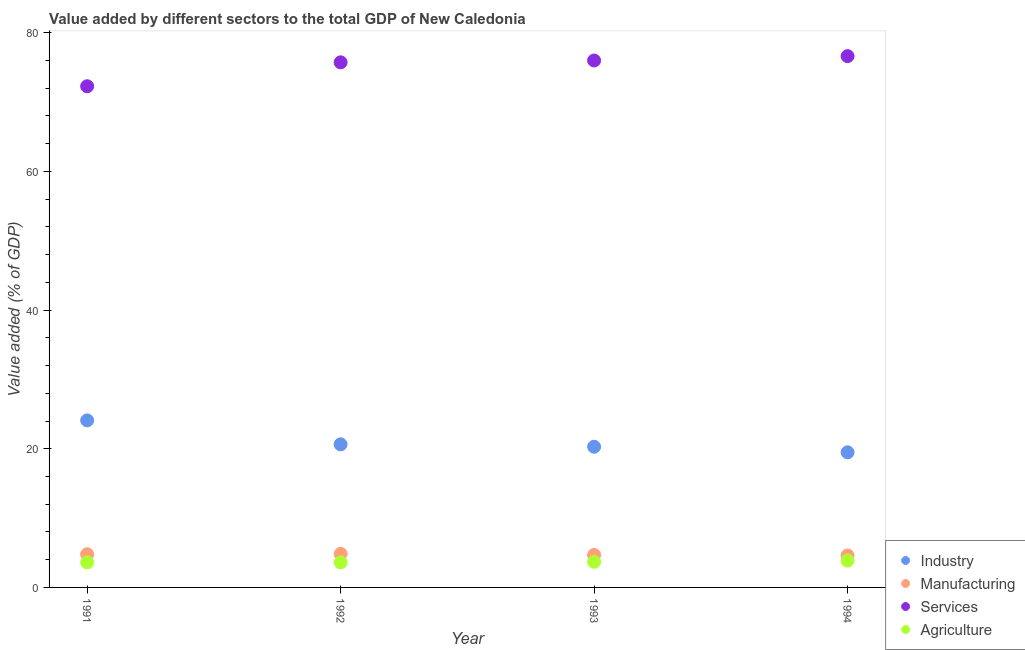What is the value added by services sector in 1993?
Provide a short and direct response. 76. Across all years, what is the maximum value added by agricultural sector?
Your answer should be compact. 3.88. Across all years, what is the minimum value added by industrial sector?
Offer a terse response. 19.49. In which year was the value added by agricultural sector minimum?
Keep it short and to the point. 1991. What is the total value added by agricultural sector in the graph?
Make the answer very short. 14.82. What is the difference between the value added by manufacturing sector in 1993 and that in 1994?
Make the answer very short. 0.08. What is the difference between the value added by industrial sector in 1993 and the value added by agricultural sector in 1992?
Offer a very short reply. 16.67. What is the average value added by industrial sector per year?
Offer a terse response. 21.13. In the year 1991, what is the difference between the value added by manufacturing sector and value added by agricultural sector?
Offer a terse response. 1.17. What is the ratio of the value added by services sector in 1992 to that in 1993?
Keep it short and to the point. 1. Is the value added by services sector in 1991 less than that in 1994?
Provide a short and direct response. Yes. Is the difference between the value added by industrial sector in 1992 and 1994 greater than the difference between the value added by services sector in 1992 and 1994?
Provide a succinct answer. Yes. What is the difference between the highest and the second highest value added by manufacturing sector?
Provide a short and direct response. 0.05. What is the difference between the highest and the lowest value added by services sector?
Make the answer very short. 4.35. In how many years, is the value added by manufacturing sector greater than the average value added by manufacturing sector taken over all years?
Your answer should be very brief. 2. Is it the case that in every year, the sum of the value added by agricultural sector and value added by services sector is greater than the sum of value added by manufacturing sector and value added by industrial sector?
Your answer should be very brief. No. Is it the case that in every year, the sum of the value added by industrial sector and value added by manufacturing sector is greater than the value added by services sector?
Offer a very short reply. No. Is the value added by industrial sector strictly greater than the value added by manufacturing sector over the years?
Your answer should be compact. Yes. Are the values on the major ticks of Y-axis written in scientific E-notation?
Offer a terse response. No. How many legend labels are there?
Provide a short and direct response. 4. How are the legend labels stacked?
Provide a short and direct response. Vertical. What is the title of the graph?
Provide a short and direct response. Value added by different sectors to the total GDP of New Caledonia. What is the label or title of the X-axis?
Provide a succinct answer. Year. What is the label or title of the Y-axis?
Ensure brevity in your answer.  Value added (% of GDP). What is the Value added (% of GDP) in Industry in 1991?
Your answer should be very brief. 24.09. What is the Value added (% of GDP) of Manufacturing in 1991?
Your answer should be very brief. 4.79. What is the Value added (% of GDP) of Services in 1991?
Give a very brief answer. 72.29. What is the Value added (% of GDP) of Agriculture in 1991?
Your answer should be compact. 3.62. What is the Value added (% of GDP) of Industry in 1992?
Provide a succinct answer. 20.64. What is the Value added (% of GDP) of Manufacturing in 1992?
Provide a succinct answer. 4.84. What is the Value added (% of GDP) of Services in 1992?
Your answer should be very brief. 75.74. What is the Value added (% of GDP) of Agriculture in 1992?
Make the answer very short. 3.62. What is the Value added (% of GDP) in Industry in 1993?
Offer a very short reply. 20.29. What is the Value added (% of GDP) in Manufacturing in 1993?
Offer a terse response. 4.69. What is the Value added (% of GDP) in Services in 1993?
Ensure brevity in your answer.  76. What is the Value added (% of GDP) of Agriculture in 1993?
Give a very brief answer. 3.7. What is the Value added (% of GDP) in Industry in 1994?
Offer a very short reply. 19.49. What is the Value added (% of GDP) of Manufacturing in 1994?
Your response must be concise. 4.61. What is the Value added (% of GDP) of Services in 1994?
Offer a very short reply. 76.63. What is the Value added (% of GDP) of Agriculture in 1994?
Give a very brief answer. 3.88. Across all years, what is the maximum Value added (% of GDP) of Industry?
Offer a terse response. 24.09. Across all years, what is the maximum Value added (% of GDP) in Manufacturing?
Offer a terse response. 4.84. Across all years, what is the maximum Value added (% of GDP) of Services?
Your answer should be compact. 76.63. Across all years, what is the maximum Value added (% of GDP) in Agriculture?
Provide a short and direct response. 3.88. Across all years, what is the minimum Value added (% of GDP) of Industry?
Give a very brief answer. 19.49. Across all years, what is the minimum Value added (% of GDP) of Manufacturing?
Your response must be concise. 4.61. Across all years, what is the minimum Value added (% of GDP) of Services?
Your answer should be very brief. 72.29. Across all years, what is the minimum Value added (% of GDP) in Agriculture?
Offer a very short reply. 3.62. What is the total Value added (% of GDP) in Industry in the graph?
Your answer should be very brief. 84.52. What is the total Value added (% of GDP) of Manufacturing in the graph?
Provide a short and direct response. 18.93. What is the total Value added (% of GDP) of Services in the graph?
Your answer should be compact. 300.67. What is the total Value added (% of GDP) of Agriculture in the graph?
Make the answer very short. 14.82. What is the difference between the Value added (% of GDP) of Industry in 1991 and that in 1992?
Keep it short and to the point. 3.45. What is the difference between the Value added (% of GDP) in Manufacturing in 1991 and that in 1992?
Ensure brevity in your answer.  -0.05. What is the difference between the Value added (% of GDP) in Services in 1991 and that in 1992?
Offer a terse response. -3.45. What is the difference between the Value added (% of GDP) in Agriculture in 1991 and that in 1992?
Provide a short and direct response. -0. What is the difference between the Value added (% of GDP) of Industry in 1991 and that in 1993?
Ensure brevity in your answer.  3.8. What is the difference between the Value added (% of GDP) in Manufacturing in 1991 and that in 1993?
Your answer should be very brief. 0.1. What is the difference between the Value added (% of GDP) in Services in 1991 and that in 1993?
Offer a very short reply. -3.72. What is the difference between the Value added (% of GDP) in Agriculture in 1991 and that in 1993?
Your answer should be compact. -0.08. What is the difference between the Value added (% of GDP) in Industry in 1991 and that in 1994?
Offer a terse response. 4.6. What is the difference between the Value added (% of GDP) of Manufacturing in 1991 and that in 1994?
Offer a very short reply. 0.18. What is the difference between the Value added (% of GDP) of Services in 1991 and that in 1994?
Offer a very short reply. -4.35. What is the difference between the Value added (% of GDP) of Agriculture in 1991 and that in 1994?
Your answer should be compact. -0.26. What is the difference between the Value added (% of GDP) of Industry in 1992 and that in 1993?
Make the answer very short. 0.35. What is the difference between the Value added (% of GDP) in Manufacturing in 1992 and that in 1993?
Your response must be concise. 0.15. What is the difference between the Value added (% of GDP) in Services in 1992 and that in 1993?
Ensure brevity in your answer.  -0.26. What is the difference between the Value added (% of GDP) in Agriculture in 1992 and that in 1993?
Provide a short and direct response. -0.08. What is the difference between the Value added (% of GDP) of Industry in 1992 and that in 1994?
Your response must be concise. 1.15. What is the difference between the Value added (% of GDP) in Manufacturing in 1992 and that in 1994?
Provide a succinct answer. 0.23. What is the difference between the Value added (% of GDP) of Services in 1992 and that in 1994?
Ensure brevity in your answer.  -0.89. What is the difference between the Value added (% of GDP) in Agriculture in 1992 and that in 1994?
Your response must be concise. -0.26. What is the difference between the Value added (% of GDP) of Industry in 1993 and that in 1994?
Keep it short and to the point. 0.8. What is the difference between the Value added (% of GDP) of Manufacturing in 1993 and that in 1994?
Provide a succinct answer. 0.08. What is the difference between the Value added (% of GDP) in Services in 1993 and that in 1994?
Your answer should be compact. -0.63. What is the difference between the Value added (% of GDP) in Agriculture in 1993 and that in 1994?
Your response must be concise. -0.17. What is the difference between the Value added (% of GDP) in Industry in 1991 and the Value added (% of GDP) in Manufacturing in 1992?
Your answer should be compact. 19.25. What is the difference between the Value added (% of GDP) in Industry in 1991 and the Value added (% of GDP) in Services in 1992?
Your answer should be compact. -51.65. What is the difference between the Value added (% of GDP) of Industry in 1991 and the Value added (% of GDP) of Agriculture in 1992?
Offer a very short reply. 20.47. What is the difference between the Value added (% of GDP) in Manufacturing in 1991 and the Value added (% of GDP) in Services in 1992?
Offer a very short reply. -70.95. What is the difference between the Value added (% of GDP) in Manufacturing in 1991 and the Value added (% of GDP) in Agriculture in 1992?
Offer a very short reply. 1.17. What is the difference between the Value added (% of GDP) of Services in 1991 and the Value added (% of GDP) of Agriculture in 1992?
Keep it short and to the point. 68.67. What is the difference between the Value added (% of GDP) of Industry in 1991 and the Value added (% of GDP) of Manufacturing in 1993?
Keep it short and to the point. 19.4. What is the difference between the Value added (% of GDP) in Industry in 1991 and the Value added (% of GDP) in Services in 1993?
Your answer should be very brief. -51.91. What is the difference between the Value added (% of GDP) in Industry in 1991 and the Value added (% of GDP) in Agriculture in 1993?
Ensure brevity in your answer.  20.39. What is the difference between the Value added (% of GDP) in Manufacturing in 1991 and the Value added (% of GDP) in Services in 1993?
Give a very brief answer. -71.22. What is the difference between the Value added (% of GDP) in Manufacturing in 1991 and the Value added (% of GDP) in Agriculture in 1993?
Ensure brevity in your answer.  1.08. What is the difference between the Value added (% of GDP) of Services in 1991 and the Value added (% of GDP) of Agriculture in 1993?
Make the answer very short. 68.59. What is the difference between the Value added (% of GDP) in Industry in 1991 and the Value added (% of GDP) in Manufacturing in 1994?
Your answer should be compact. 19.48. What is the difference between the Value added (% of GDP) in Industry in 1991 and the Value added (% of GDP) in Services in 1994?
Make the answer very short. -52.54. What is the difference between the Value added (% of GDP) in Industry in 1991 and the Value added (% of GDP) in Agriculture in 1994?
Offer a terse response. 20.22. What is the difference between the Value added (% of GDP) of Manufacturing in 1991 and the Value added (% of GDP) of Services in 1994?
Your answer should be very brief. -71.85. What is the difference between the Value added (% of GDP) of Manufacturing in 1991 and the Value added (% of GDP) of Agriculture in 1994?
Give a very brief answer. 0.91. What is the difference between the Value added (% of GDP) of Services in 1991 and the Value added (% of GDP) of Agriculture in 1994?
Your response must be concise. 68.41. What is the difference between the Value added (% of GDP) in Industry in 1992 and the Value added (% of GDP) in Manufacturing in 1993?
Give a very brief answer. 15.95. What is the difference between the Value added (% of GDP) in Industry in 1992 and the Value added (% of GDP) in Services in 1993?
Make the answer very short. -55.36. What is the difference between the Value added (% of GDP) of Industry in 1992 and the Value added (% of GDP) of Agriculture in 1993?
Provide a short and direct response. 16.94. What is the difference between the Value added (% of GDP) in Manufacturing in 1992 and the Value added (% of GDP) in Services in 1993?
Provide a succinct answer. -71.16. What is the difference between the Value added (% of GDP) of Manufacturing in 1992 and the Value added (% of GDP) of Agriculture in 1993?
Keep it short and to the point. 1.14. What is the difference between the Value added (% of GDP) of Services in 1992 and the Value added (% of GDP) of Agriculture in 1993?
Offer a very short reply. 72.04. What is the difference between the Value added (% of GDP) in Industry in 1992 and the Value added (% of GDP) in Manufacturing in 1994?
Your response must be concise. 16.03. What is the difference between the Value added (% of GDP) in Industry in 1992 and the Value added (% of GDP) in Services in 1994?
Make the answer very short. -55.99. What is the difference between the Value added (% of GDP) in Industry in 1992 and the Value added (% of GDP) in Agriculture in 1994?
Provide a succinct answer. 16.76. What is the difference between the Value added (% of GDP) in Manufacturing in 1992 and the Value added (% of GDP) in Services in 1994?
Keep it short and to the point. -71.79. What is the difference between the Value added (% of GDP) in Manufacturing in 1992 and the Value added (% of GDP) in Agriculture in 1994?
Make the answer very short. 0.96. What is the difference between the Value added (% of GDP) in Services in 1992 and the Value added (% of GDP) in Agriculture in 1994?
Provide a short and direct response. 71.86. What is the difference between the Value added (% of GDP) in Industry in 1993 and the Value added (% of GDP) in Manufacturing in 1994?
Make the answer very short. 15.68. What is the difference between the Value added (% of GDP) of Industry in 1993 and the Value added (% of GDP) of Services in 1994?
Keep it short and to the point. -56.34. What is the difference between the Value added (% of GDP) of Industry in 1993 and the Value added (% of GDP) of Agriculture in 1994?
Make the answer very short. 16.42. What is the difference between the Value added (% of GDP) in Manufacturing in 1993 and the Value added (% of GDP) in Services in 1994?
Make the answer very short. -71.95. What is the difference between the Value added (% of GDP) in Manufacturing in 1993 and the Value added (% of GDP) in Agriculture in 1994?
Ensure brevity in your answer.  0.81. What is the difference between the Value added (% of GDP) of Services in 1993 and the Value added (% of GDP) of Agriculture in 1994?
Make the answer very short. 72.13. What is the average Value added (% of GDP) of Industry per year?
Provide a succinct answer. 21.13. What is the average Value added (% of GDP) in Manufacturing per year?
Keep it short and to the point. 4.73. What is the average Value added (% of GDP) in Services per year?
Provide a short and direct response. 75.17. What is the average Value added (% of GDP) in Agriculture per year?
Make the answer very short. 3.7. In the year 1991, what is the difference between the Value added (% of GDP) of Industry and Value added (% of GDP) of Manufacturing?
Ensure brevity in your answer.  19.31. In the year 1991, what is the difference between the Value added (% of GDP) of Industry and Value added (% of GDP) of Services?
Provide a short and direct response. -48.19. In the year 1991, what is the difference between the Value added (% of GDP) of Industry and Value added (% of GDP) of Agriculture?
Make the answer very short. 20.47. In the year 1991, what is the difference between the Value added (% of GDP) in Manufacturing and Value added (% of GDP) in Services?
Make the answer very short. -67.5. In the year 1991, what is the difference between the Value added (% of GDP) in Manufacturing and Value added (% of GDP) in Agriculture?
Offer a very short reply. 1.17. In the year 1991, what is the difference between the Value added (% of GDP) of Services and Value added (% of GDP) of Agriculture?
Your response must be concise. 68.67. In the year 1992, what is the difference between the Value added (% of GDP) in Industry and Value added (% of GDP) in Manufacturing?
Provide a short and direct response. 15.8. In the year 1992, what is the difference between the Value added (% of GDP) in Industry and Value added (% of GDP) in Services?
Give a very brief answer. -55.1. In the year 1992, what is the difference between the Value added (% of GDP) in Industry and Value added (% of GDP) in Agriculture?
Make the answer very short. 17.02. In the year 1992, what is the difference between the Value added (% of GDP) in Manufacturing and Value added (% of GDP) in Services?
Your answer should be compact. -70.9. In the year 1992, what is the difference between the Value added (% of GDP) of Manufacturing and Value added (% of GDP) of Agriculture?
Your answer should be compact. 1.22. In the year 1992, what is the difference between the Value added (% of GDP) of Services and Value added (% of GDP) of Agriculture?
Ensure brevity in your answer.  72.12. In the year 1993, what is the difference between the Value added (% of GDP) in Industry and Value added (% of GDP) in Manufacturing?
Give a very brief answer. 15.6. In the year 1993, what is the difference between the Value added (% of GDP) of Industry and Value added (% of GDP) of Services?
Your answer should be very brief. -55.71. In the year 1993, what is the difference between the Value added (% of GDP) of Industry and Value added (% of GDP) of Agriculture?
Your answer should be compact. 16.59. In the year 1993, what is the difference between the Value added (% of GDP) in Manufacturing and Value added (% of GDP) in Services?
Provide a short and direct response. -71.32. In the year 1993, what is the difference between the Value added (% of GDP) in Manufacturing and Value added (% of GDP) in Agriculture?
Ensure brevity in your answer.  0.99. In the year 1993, what is the difference between the Value added (% of GDP) in Services and Value added (% of GDP) in Agriculture?
Give a very brief answer. 72.3. In the year 1994, what is the difference between the Value added (% of GDP) of Industry and Value added (% of GDP) of Manufacturing?
Offer a very short reply. 14.88. In the year 1994, what is the difference between the Value added (% of GDP) in Industry and Value added (% of GDP) in Services?
Provide a succinct answer. -57.14. In the year 1994, what is the difference between the Value added (% of GDP) in Industry and Value added (% of GDP) in Agriculture?
Offer a terse response. 15.61. In the year 1994, what is the difference between the Value added (% of GDP) in Manufacturing and Value added (% of GDP) in Services?
Provide a succinct answer. -72.02. In the year 1994, what is the difference between the Value added (% of GDP) of Manufacturing and Value added (% of GDP) of Agriculture?
Your answer should be compact. 0.73. In the year 1994, what is the difference between the Value added (% of GDP) of Services and Value added (% of GDP) of Agriculture?
Offer a very short reply. 72.76. What is the ratio of the Value added (% of GDP) in Industry in 1991 to that in 1992?
Give a very brief answer. 1.17. What is the ratio of the Value added (% of GDP) in Manufacturing in 1991 to that in 1992?
Your response must be concise. 0.99. What is the ratio of the Value added (% of GDP) in Services in 1991 to that in 1992?
Offer a very short reply. 0.95. What is the ratio of the Value added (% of GDP) of Industry in 1991 to that in 1993?
Offer a terse response. 1.19. What is the ratio of the Value added (% of GDP) in Manufacturing in 1991 to that in 1993?
Provide a succinct answer. 1.02. What is the ratio of the Value added (% of GDP) in Services in 1991 to that in 1993?
Give a very brief answer. 0.95. What is the ratio of the Value added (% of GDP) in Agriculture in 1991 to that in 1993?
Your answer should be compact. 0.98. What is the ratio of the Value added (% of GDP) of Industry in 1991 to that in 1994?
Keep it short and to the point. 1.24. What is the ratio of the Value added (% of GDP) in Manufacturing in 1991 to that in 1994?
Make the answer very short. 1.04. What is the ratio of the Value added (% of GDP) in Services in 1991 to that in 1994?
Give a very brief answer. 0.94. What is the ratio of the Value added (% of GDP) of Agriculture in 1991 to that in 1994?
Your answer should be very brief. 0.93. What is the ratio of the Value added (% of GDP) in Industry in 1992 to that in 1993?
Provide a short and direct response. 1.02. What is the ratio of the Value added (% of GDP) of Manufacturing in 1992 to that in 1993?
Your answer should be compact. 1.03. What is the ratio of the Value added (% of GDP) of Services in 1992 to that in 1993?
Keep it short and to the point. 1. What is the ratio of the Value added (% of GDP) in Agriculture in 1992 to that in 1993?
Offer a very short reply. 0.98. What is the ratio of the Value added (% of GDP) of Industry in 1992 to that in 1994?
Your answer should be compact. 1.06. What is the ratio of the Value added (% of GDP) in Services in 1992 to that in 1994?
Ensure brevity in your answer.  0.99. What is the ratio of the Value added (% of GDP) of Agriculture in 1992 to that in 1994?
Your answer should be very brief. 0.93. What is the ratio of the Value added (% of GDP) of Industry in 1993 to that in 1994?
Offer a very short reply. 1.04. What is the ratio of the Value added (% of GDP) in Manufacturing in 1993 to that in 1994?
Ensure brevity in your answer.  1.02. What is the ratio of the Value added (% of GDP) of Agriculture in 1993 to that in 1994?
Your answer should be very brief. 0.96. What is the difference between the highest and the second highest Value added (% of GDP) in Industry?
Your answer should be very brief. 3.45. What is the difference between the highest and the second highest Value added (% of GDP) of Manufacturing?
Your response must be concise. 0.05. What is the difference between the highest and the second highest Value added (% of GDP) of Services?
Make the answer very short. 0.63. What is the difference between the highest and the second highest Value added (% of GDP) of Agriculture?
Offer a terse response. 0.17. What is the difference between the highest and the lowest Value added (% of GDP) of Industry?
Provide a succinct answer. 4.6. What is the difference between the highest and the lowest Value added (% of GDP) of Manufacturing?
Your answer should be very brief. 0.23. What is the difference between the highest and the lowest Value added (% of GDP) in Services?
Your response must be concise. 4.35. What is the difference between the highest and the lowest Value added (% of GDP) of Agriculture?
Give a very brief answer. 0.26. 